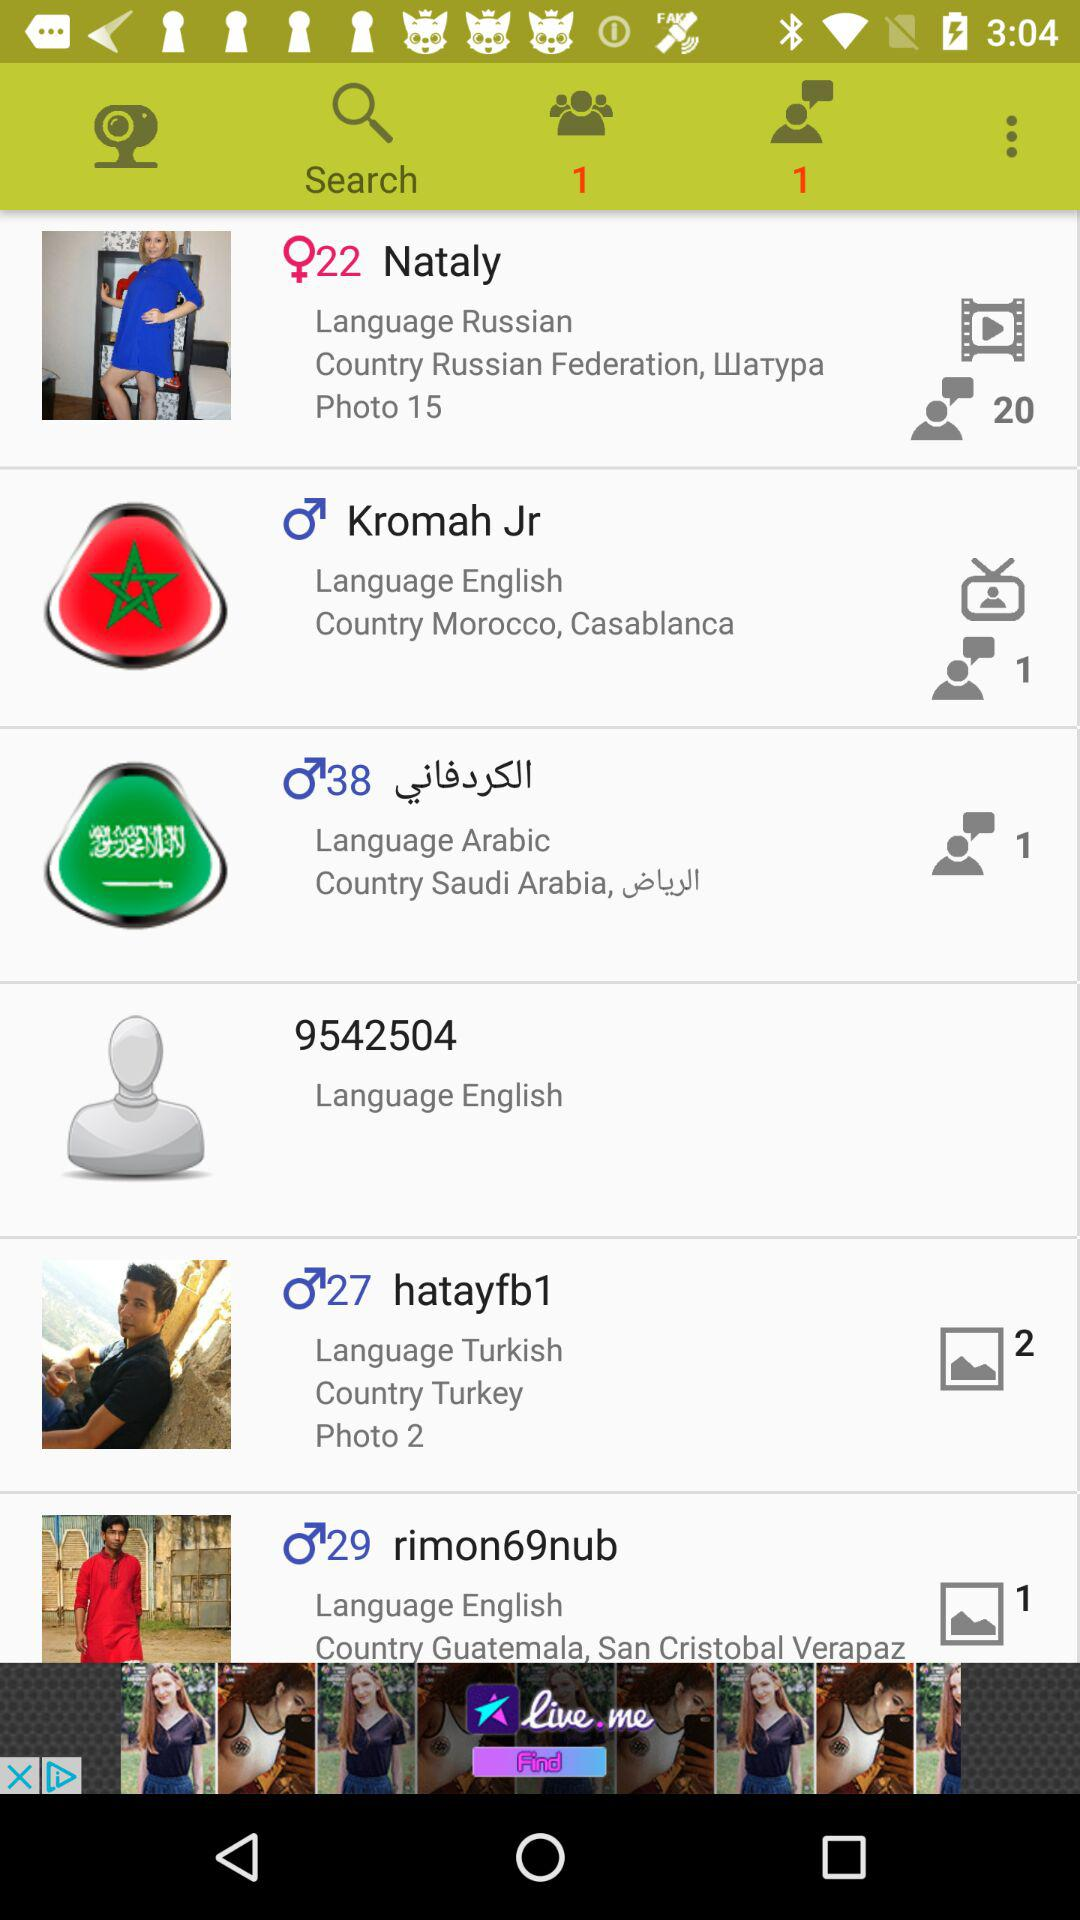What is the number of new messages? The number of new messages is 1. 